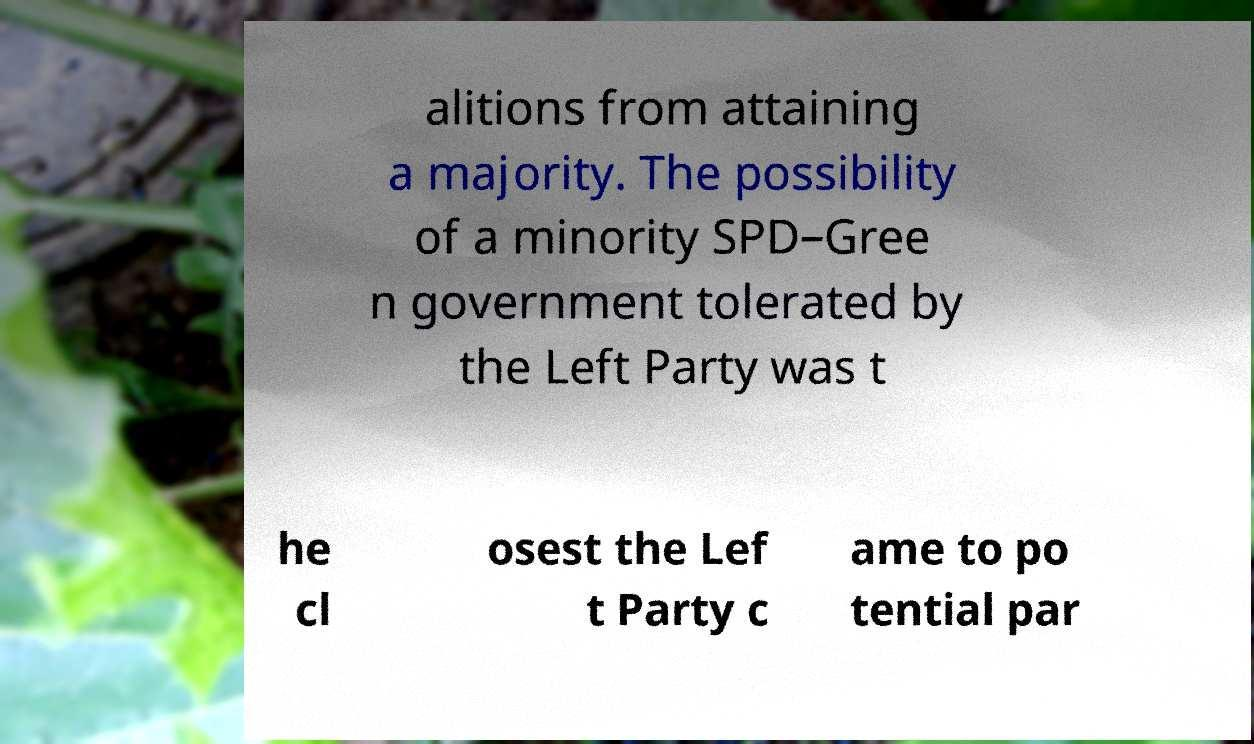Can you accurately transcribe the text from the provided image for me? alitions from attaining a majority. The possibility of a minority SPD–Gree n government tolerated by the Left Party was t he cl osest the Lef t Party c ame to po tential par 